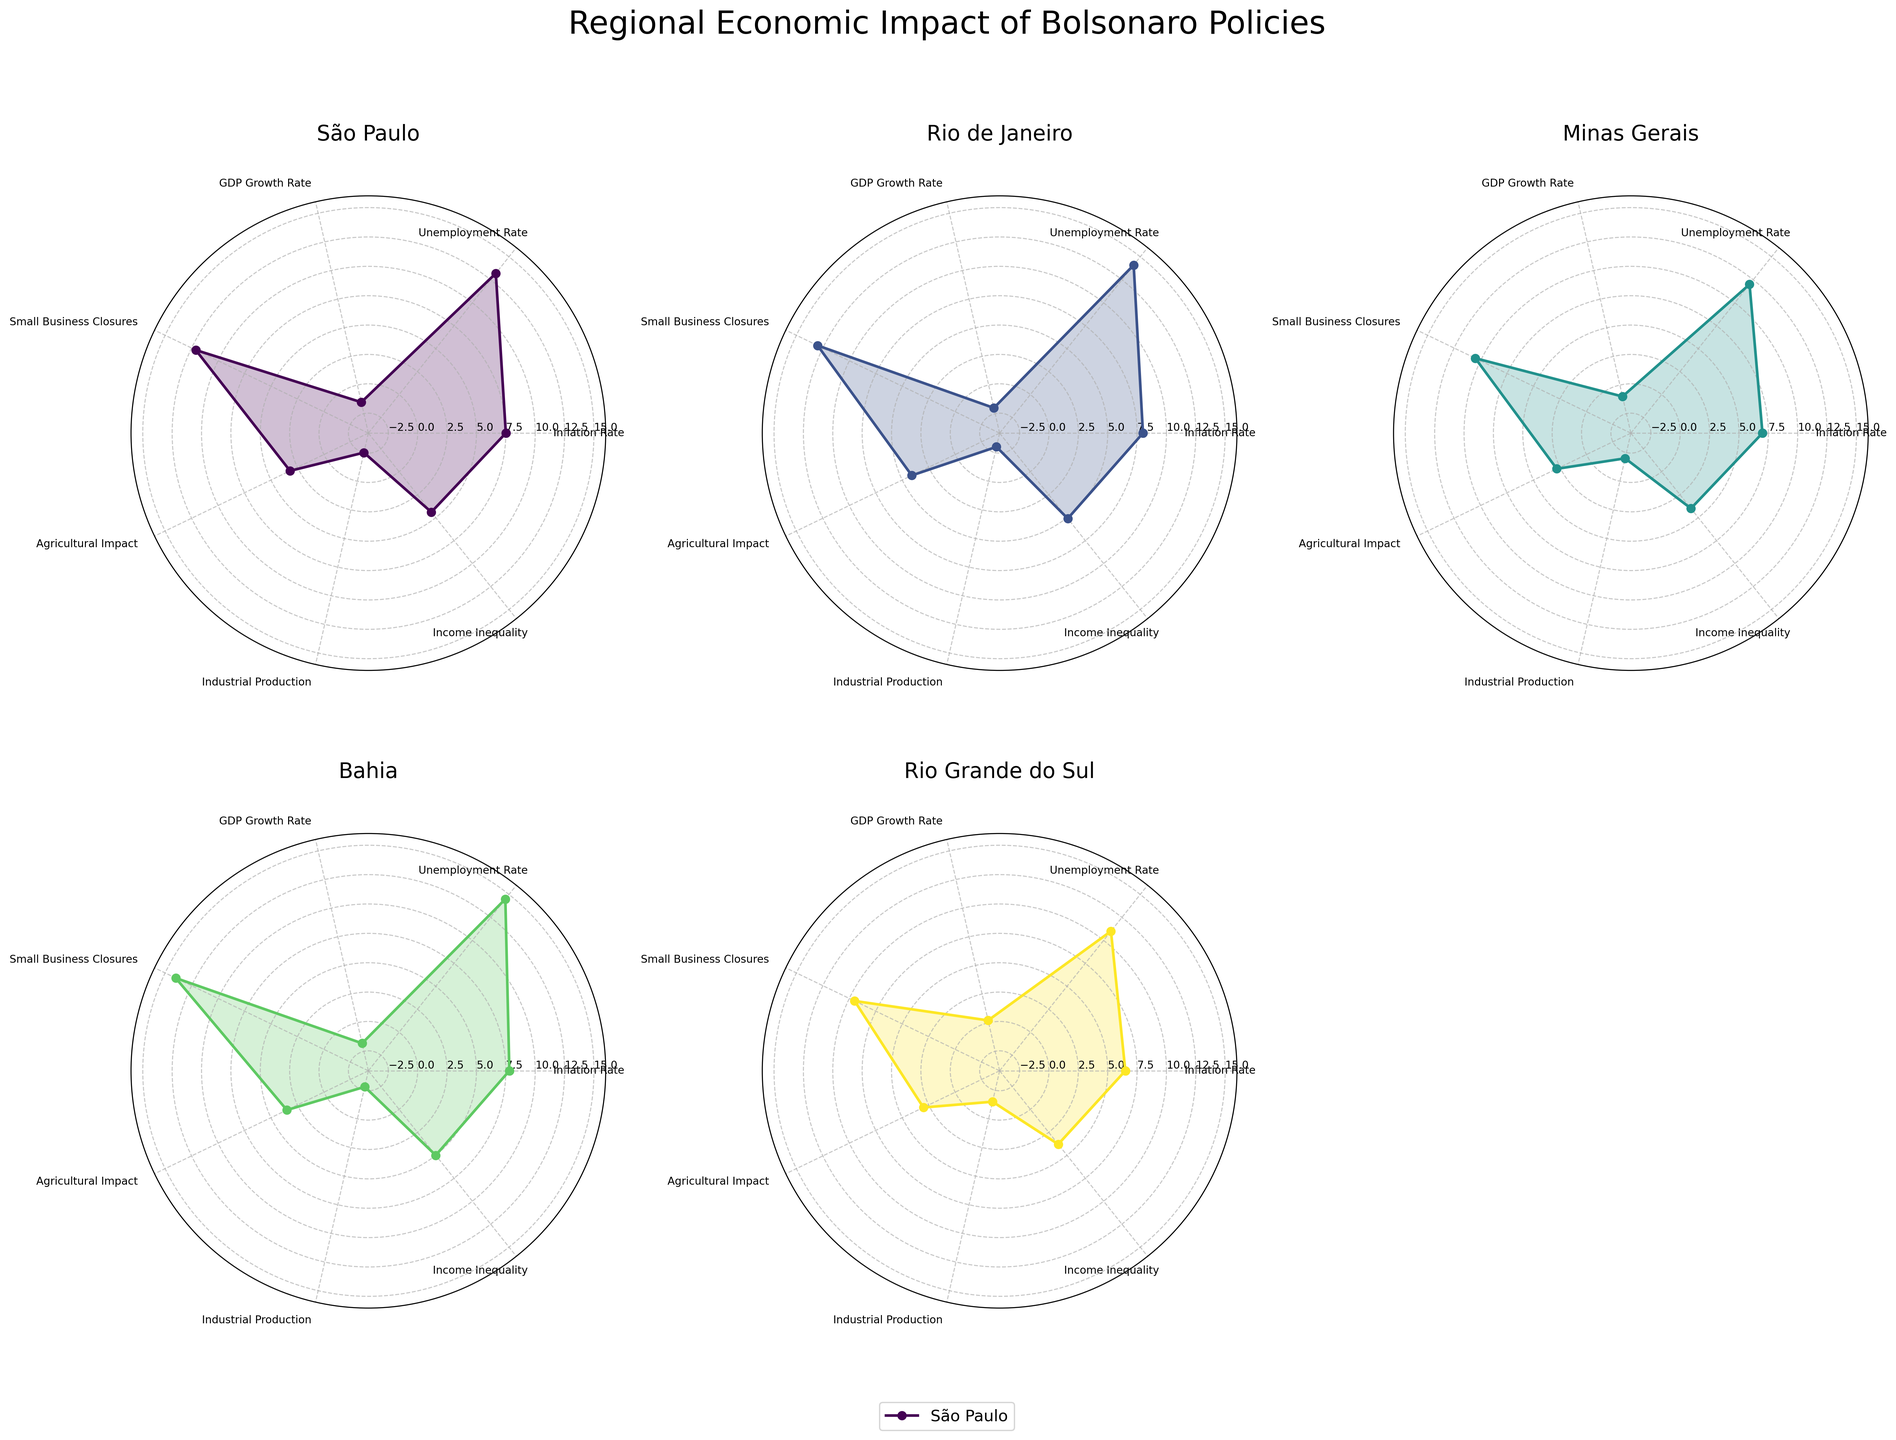What is the title of the figure? The title is usually located at the top of the figure and provides a brief description of what the chart is about. In this case, the provided code specifies the title of the figure as "Regional Economic Impact of Bolsonaro Policies".
Answer: Regional Economic Impact of Bolsonaro Policies Which state shows the highest value for Unemployment Rate? Look at the specific radar chart sections for each state. Identify the state where the Unemployment Rate reaches the highest peak. São Paulo, Rio de Janeiro, Minas Gerais, Bahia, and Rio Grande do Sul are the states compared.
Answer: Pernambuco How does the Industrial Production of Bahia compare to that of São Paulo? Observe the "Industrial Production" axis on the radar charts for both Bahia and São Paulo. Identify whether Bahia or São Paulo has a higher or lower value by seeing how far the point extends from the center.
Answer: São Paulo has a higher drop (-2.5) compared to Bahia (-2.8) Which state has the lowest Small Business Closures rate? Check the "Small Business Closures" axis for each state and identify which state has the point closest to the central point of the radar chart.
Answer: Santa Catarina Which state has the most balanced data across all categories? To determine balance, look for a state whose radar chart shows values that are closer to being equally distanced from the center across all categories. This means its web will appear more circular rather than spiky.
Answer: Santa Catarina What is the difference in GDP Growth Rate between Paraná and Bahia? Look at the "GDP Growth Rate" axes for Paraná and Bahia. Note the values for each state. Paraná is 0.0, and Bahia is -1.8. Calculate the difference by subtracting one from the other.
Answer: 1.8 Which state shows a positive GDP Growth Rate? Positive GDP Growth Rates extend outward from the center in the radar chart. Look at the "GDP Growth Rate" axis for each state and find any state that extends outward from the center point.
Answer: Rio Grande do Sul What's the average Income Inequality for the top 5 states? Locate the "Income Inequality" section on the radar charts for the top 5 states (São Paulo, Rio de Janeiro, Minas Gerais, Bahia, Rio Grande do Sul). Add their values and divide by 5.
Answer: (4.4 + 5.1 + 4.0 + 5.0 + 3.8) / 5 = 4.46 